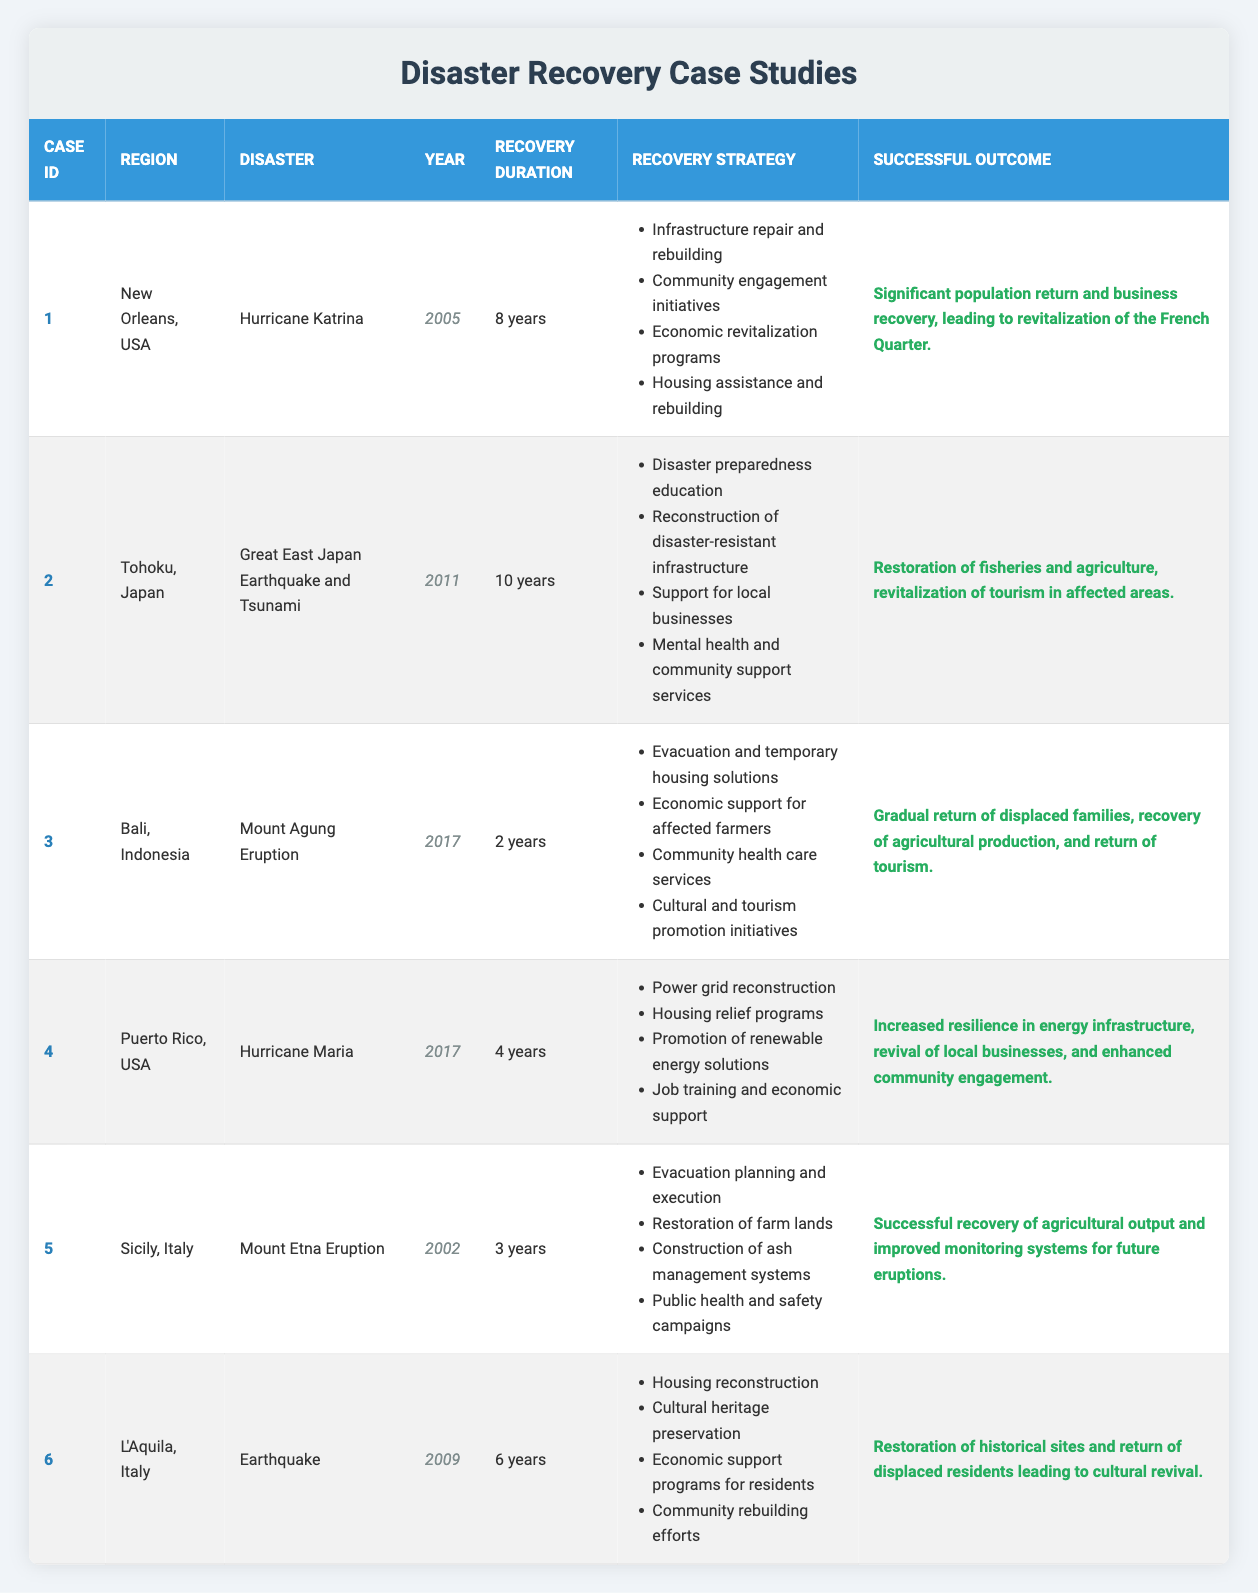What is the region affected by Hurricane Maria? The table indicates that Hurricane Maria affected Puerto Rico, USA.
Answer: Puerto Rico, USA How long did the recovery take in New Orleans after Hurricane Katrina? The duration of recovery listed for New Orleans after Hurricane Katrina is 8 years.
Answer: 8 years Which region had the shortest recovery duration? By comparing the recovery durations from the table, Bali, Indonesia had the shortest recovery duration at 2 years.
Answer: Bali, Indonesia Did the recovery strategies for the Great East Japan Earthquake include mental health services? The table shows that mental health and community support services were part of the recovery strategy for the Great East Japan Earthquake and Tsunami. Therefore, the answer is yes.
Answer: Yes How many years did it take to recover from the Mount Etna Eruption in Sicily? The table states that the recovery duration for the Mount Etna Eruption in Sicily was 3 years.
Answer: 3 years What successful outcome was achieved in L'Aquila, Italy after the earthquake? The outcome for L'Aquila, Italy specified in the table is the restoration of historical sites and the return of displaced residents leading to cultural revival.
Answer: Restoration of historical sites and cultural revival What is the average recovery duration of all the listed case studies? To find the average recovery duration, we first convert the durations to years: 8, 10, 2, 4, 3, 6. Summing these gives us 33 years total. Dividing by the total number of case studies (6) results in an average of 5.5 years.
Answer: 5.5 years Which case study included housing assistance as a recovery strategy? From the table, the case study for Hurricane Katrina in New Orleans included housing assistance and rebuilding as one of its recovery strategies.
Answer: Hurricane Katrina (New Orleans) 